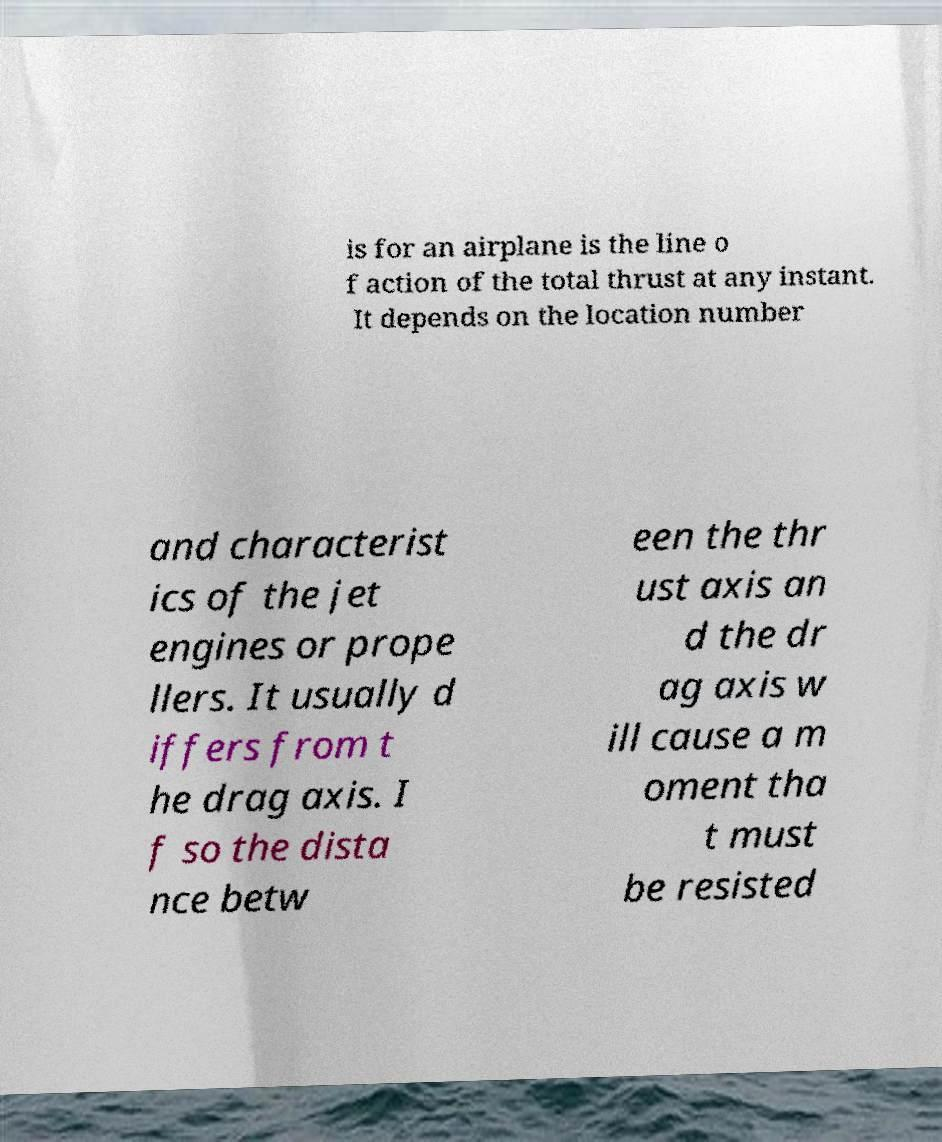Can you read and provide the text displayed in the image?This photo seems to have some interesting text. Can you extract and type it out for me? is for an airplane is the line o f action of the total thrust at any instant. It depends on the location number and characterist ics of the jet engines or prope llers. It usually d iffers from t he drag axis. I f so the dista nce betw een the thr ust axis an d the dr ag axis w ill cause a m oment tha t must be resisted 